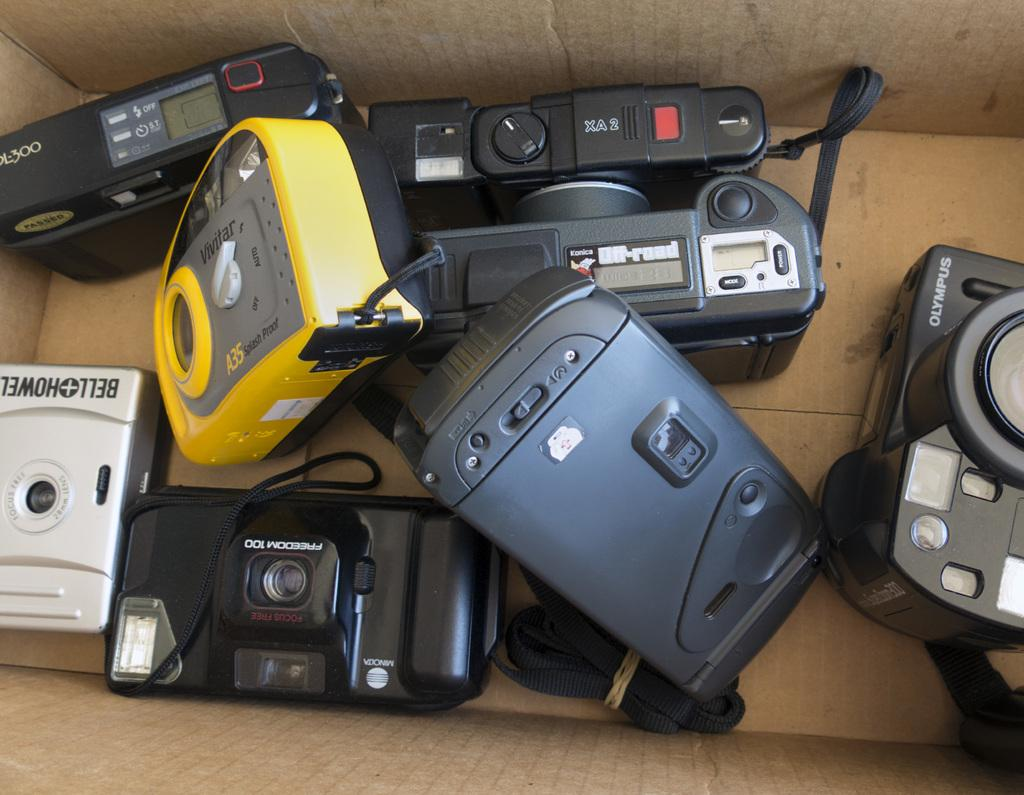What is the main subject of the image? The main subject of the image is different models of cameras. How are the cameras stored in the image? The cameras are kept in a cardboard box. Can you describe the color of one of the cameras in the image? One of the cameras appears to be yellow in color. What type of caption is written on the cardboard box in the image? There is no caption written on the cardboard box in the image. How much dirt is visible on the cameras in the image? There is no dirt visible on the cameras in the image. 